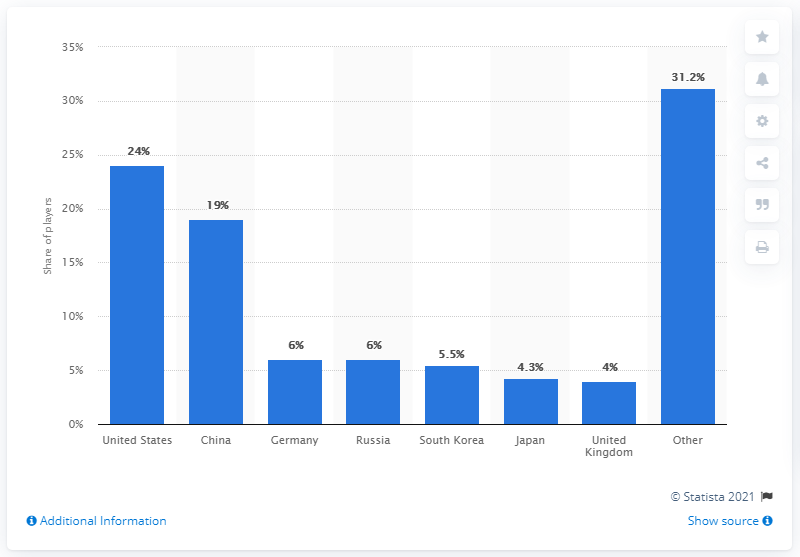Outline some significant characteristics in this image. The second bar from the left represents China. According to data, 19% of PUBG players are from China The distribution of pubg players in the United Kingdom and the other country has the largest difference between two adjacent bars. According to recent data, over 19% of all PUBG players are from China. 